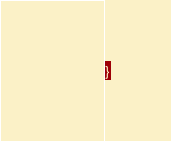<code> <loc_0><loc_0><loc_500><loc_500><_CSS_>}
</code> 